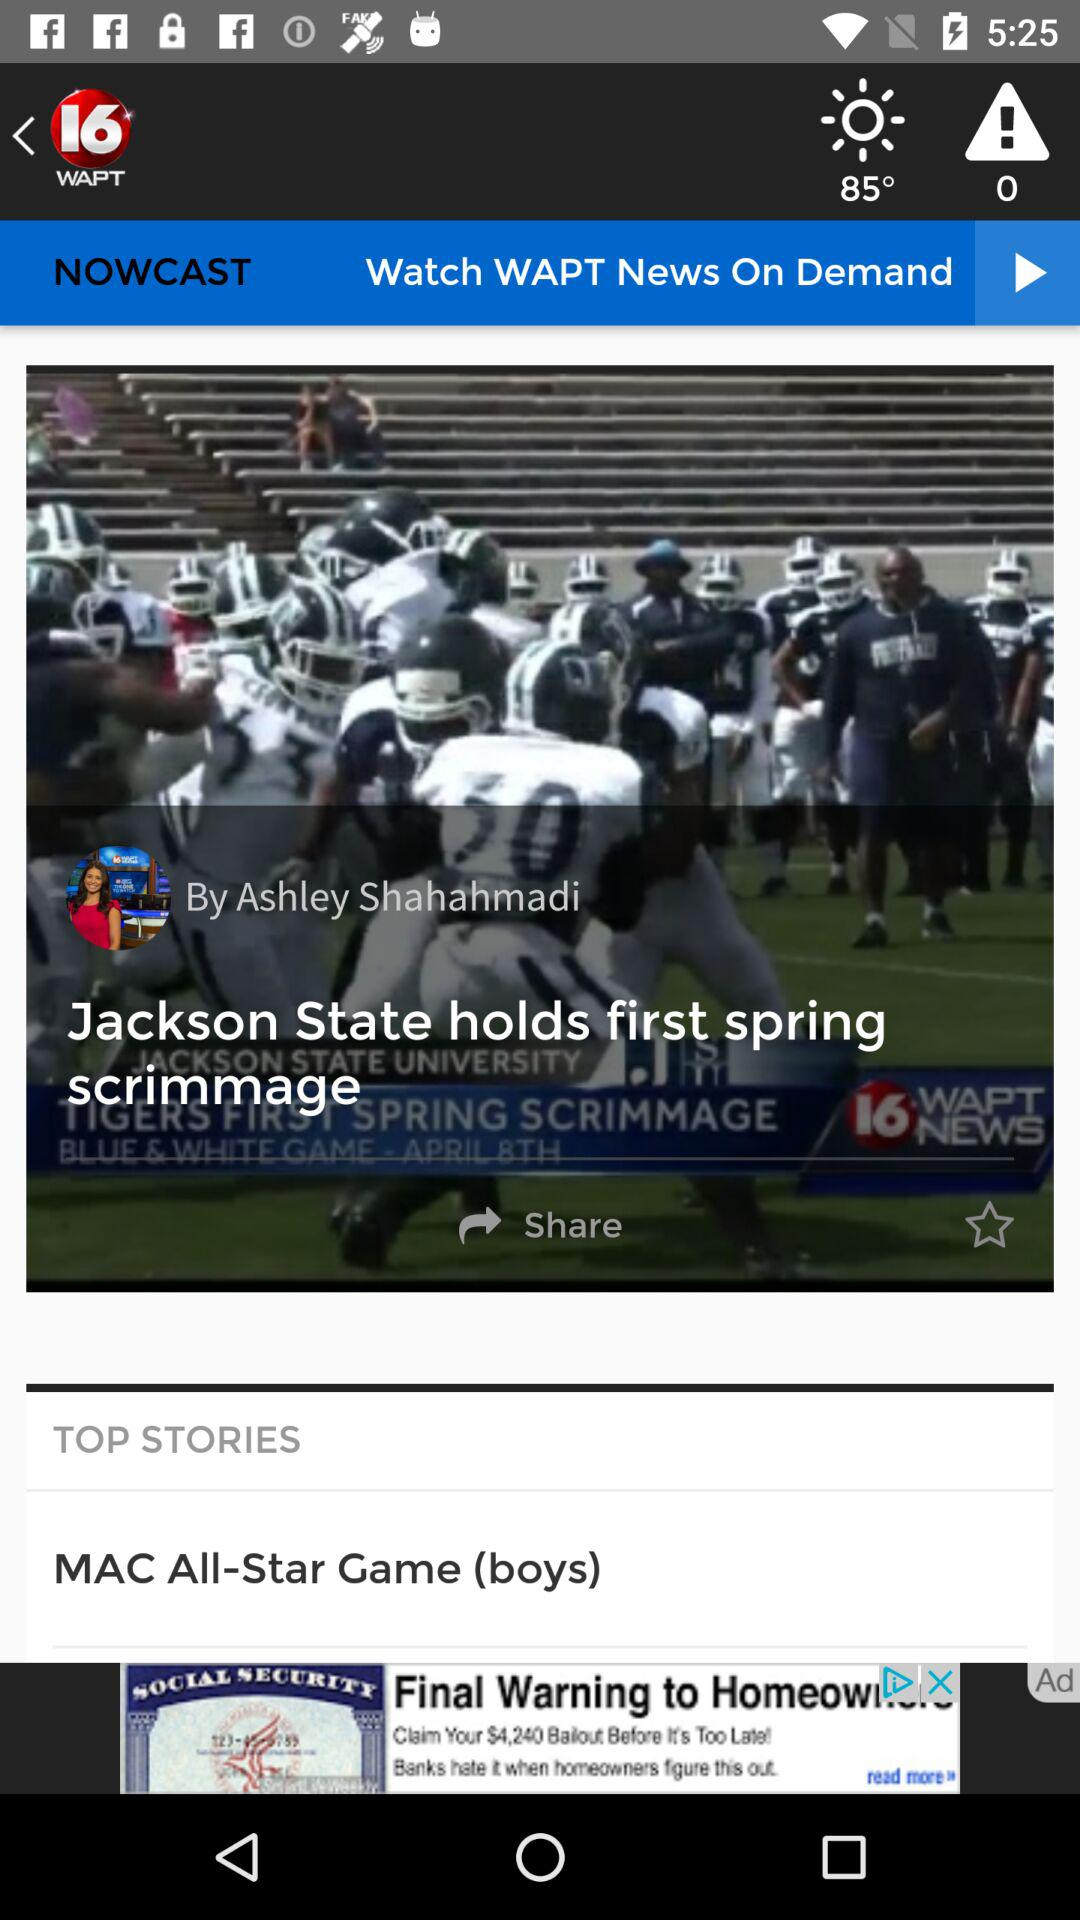What is the temperature? The temperature is 85 degrees. 